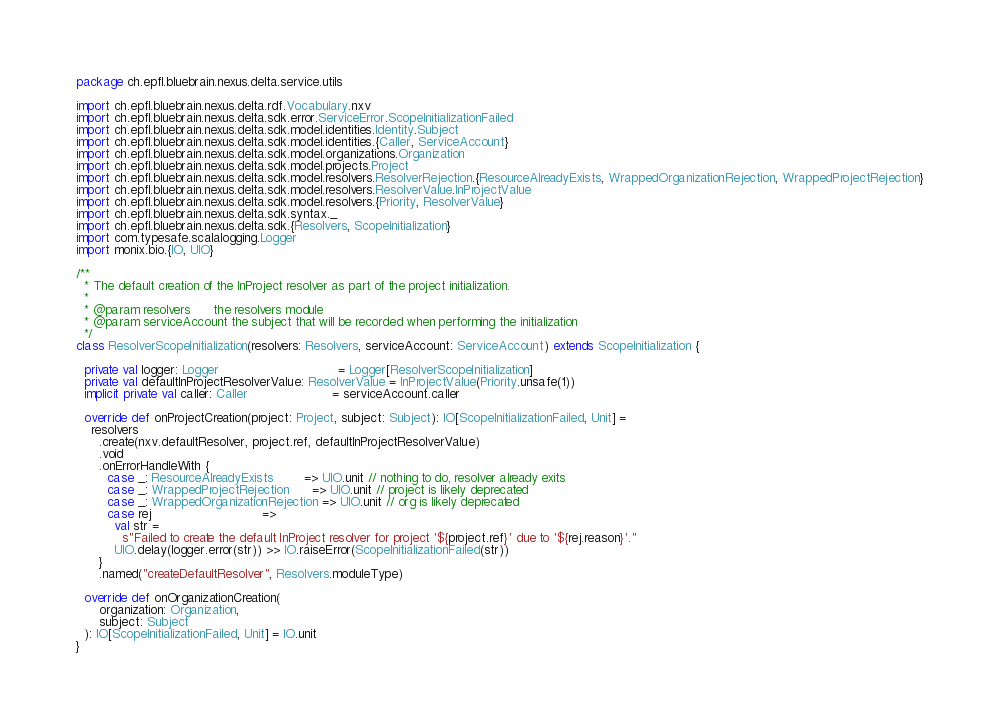Convert code to text. <code><loc_0><loc_0><loc_500><loc_500><_Scala_>package ch.epfl.bluebrain.nexus.delta.service.utils

import ch.epfl.bluebrain.nexus.delta.rdf.Vocabulary.nxv
import ch.epfl.bluebrain.nexus.delta.sdk.error.ServiceError.ScopeInitializationFailed
import ch.epfl.bluebrain.nexus.delta.sdk.model.identities.Identity.Subject
import ch.epfl.bluebrain.nexus.delta.sdk.model.identities.{Caller, ServiceAccount}
import ch.epfl.bluebrain.nexus.delta.sdk.model.organizations.Organization
import ch.epfl.bluebrain.nexus.delta.sdk.model.projects.Project
import ch.epfl.bluebrain.nexus.delta.sdk.model.resolvers.ResolverRejection.{ResourceAlreadyExists, WrappedOrganizationRejection, WrappedProjectRejection}
import ch.epfl.bluebrain.nexus.delta.sdk.model.resolvers.ResolverValue.InProjectValue
import ch.epfl.bluebrain.nexus.delta.sdk.model.resolvers.{Priority, ResolverValue}
import ch.epfl.bluebrain.nexus.delta.sdk.syntax._
import ch.epfl.bluebrain.nexus.delta.sdk.{Resolvers, ScopeInitialization}
import com.typesafe.scalalogging.Logger
import monix.bio.{IO, UIO}

/**
  * The default creation of the InProject resolver as part of the project initialization.
  *
  * @param resolvers      the resolvers module
  * @param serviceAccount the subject that will be recorded when performing the initialization
  */
class ResolverScopeInitialization(resolvers: Resolvers, serviceAccount: ServiceAccount) extends ScopeInitialization {

  private val logger: Logger                               = Logger[ResolverScopeInitialization]
  private val defaultInProjectResolverValue: ResolverValue = InProjectValue(Priority.unsafe(1))
  implicit private val caller: Caller                      = serviceAccount.caller

  override def onProjectCreation(project: Project, subject: Subject): IO[ScopeInitializationFailed, Unit] =
    resolvers
      .create(nxv.defaultResolver, project.ref, defaultInProjectResolverValue)
      .void
      .onErrorHandleWith {
        case _: ResourceAlreadyExists        => UIO.unit // nothing to do, resolver already exits
        case _: WrappedProjectRejection      => UIO.unit // project is likely deprecated
        case _: WrappedOrganizationRejection => UIO.unit // org is likely deprecated
        case rej                             =>
          val str =
            s"Failed to create the default InProject resolver for project '${project.ref}' due to '${rej.reason}'."
          UIO.delay(logger.error(str)) >> IO.raiseError(ScopeInitializationFailed(str))
      }
      .named("createDefaultResolver", Resolvers.moduleType)

  override def onOrganizationCreation(
      organization: Organization,
      subject: Subject
  ): IO[ScopeInitializationFailed, Unit] = IO.unit
}
</code> 